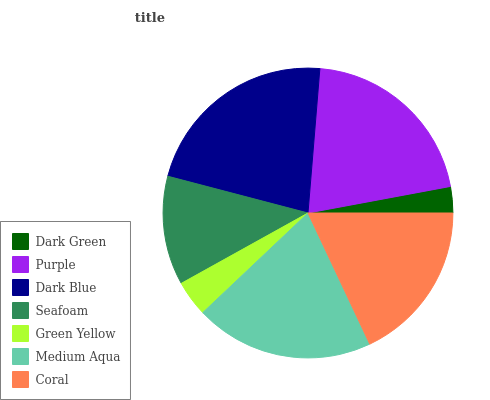Is Dark Green the minimum?
Answer yes or no. Yes. Is Dark Blue the maximum?
Answer yes or no. Yes. Is Purple the minimum?
Answer yes or no. No. Is Purple the maximum?
Answer yes or no. No. Is Purple greater than Dark Green?
Answer yes or no. Yes. Is Dark Green less than Purple?
Answer yes or no. Yes. Is Dark Green greater than Purple?
Answer yes or no. No. Is Purple less than Dark Green?
Answer yes or no. No. Is Coral the high median?
Answer yes or no. Yes. Is Coral the low median?
Answer yes or no. Yes. Is Green Yellow the high median?
Answer yes or no. No. Is Dark Green the low median?
Answer yes or no. No. 